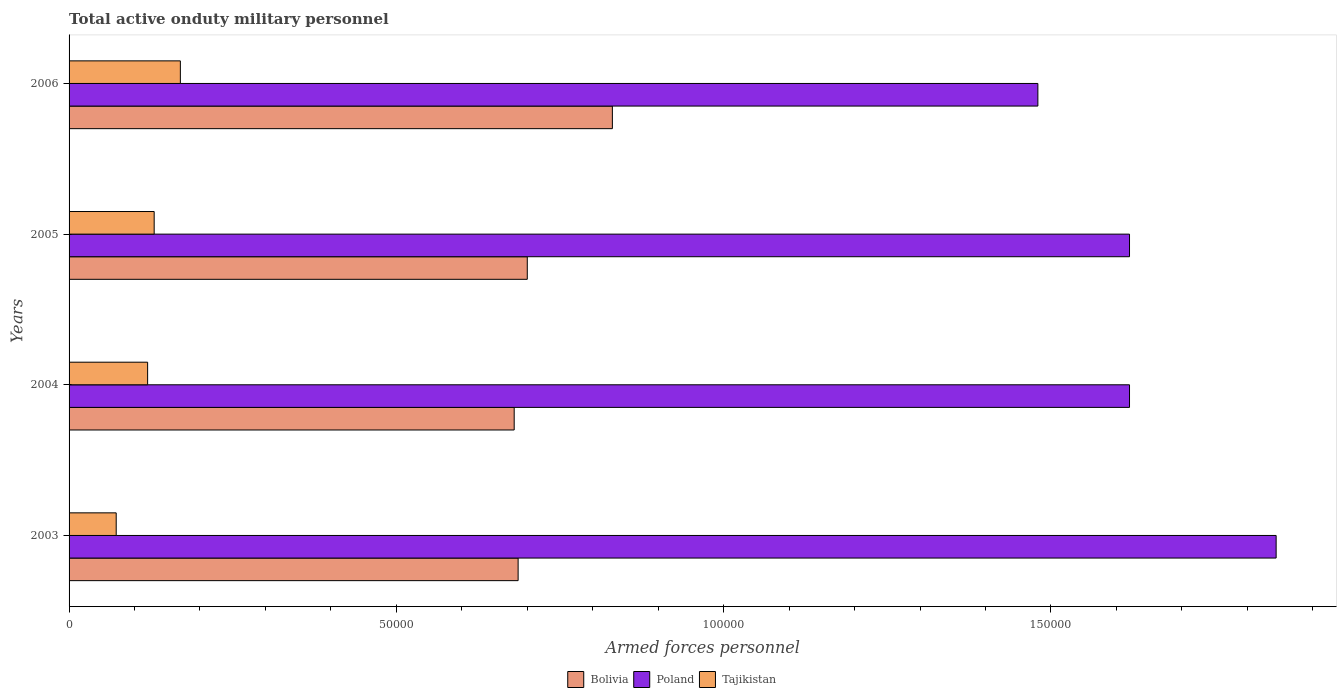How many different coloured bars are there?
Provide a succinct answer. 3. How many groups of bars are there?
Provide a short and direct response. 4. What is the number of armed forces personnel in Poland in 2004?
Make the answer very short. 1.62e+05. Across all years, what is the maximum number of armed forces personnel in Tajikistan?
Give a very brief answer. 1.70e+04. Across all years, what is the minimum number of armed forces personnel in Bolivia?
Make the answer very short. 6.80e+04. What is the total number of armed forces personnel in Poland in the graph?
Keep it short and to the point. 6.56e+05. What is the difference between the number of armed forces personnel in Tajikistan in 2003 and that in 2004?
Provide a succinct answer. -4800. What is the difference between the number of armed forces personnel in Tajikistan in 2004 and the number of armed forces personnel in Bolivia in 2006?
Keep it short and to the point. -7.10e+04. What is the average number of armed forces personnel in Bolivia per year?
Provide a short and direct response. 7.24e+04. In the year 2005, what is the difference between the number of armed forces personnel in Tajikistan and number of armed forces personnel in Poland?
Offer a terse response. -1.49e+05. What is the ratio of the number of armed forces personnel in Tajikistan in 2003 to that in 2006?
Your response must be concise. 0.42. Is the number of armed forces personnel in Poland in 2004 less than that in 2005?
Offer a very short reply. No. What is the difference between the highest and the second highest number of armed forces personnel in Bolivia?
Offer a terse response. 1.30e+04. What is the difference between the highest and the lowest number of armed forces personnel in Bolivia?
Offer a very short reply. 1.50e+04. What does the 1st bar from the top in 2005 represents?
Provide a succinct answer. Tajikistan. What does the 1st bar from the bottom in 2004 represents?
Provide a short and direct response. Bolivia. Are all the bars in the graph horizontal?
Offer a very short reply. Yes. Are the values on the major ticks of X-axis written in scientific E-notation?
Give a very brief answer. No. Does the graph contain grids?
Provide a short and direct response. No. Where does the legend appear in the graph?
Provide a short and direct response. Bottom center. How many legend labels are there?
Offer a terse response. 3. What is the title of the graph?
Provide a short and direct response. Total active onduty military personnel. What is the label or title of the X-axis?
Provide a short and direct response. Armed forces personnel. What is the label or title of the Y-axis?
Your answer should be compact. Years. What is the Armed forces personnel of Bolivia in 2003?
Keep it short and to the point. 6.86e+04. What is the Armed forces personnel in Poland in 2003?
Offer a terse response. 1.84e+05. What is the Armed forces personnel in Tajikistan in 2003?
Ensure brevity in your answer.  7200. What is the Armed forces personnel of Bolivia in 2004?
Ensure brevity in your answer.  6.80e+04. What is the Armed forces personnel in Poland in 2004?
Your answer should be very brief. 1.62e+05. What is the Armed forces personnel in Tajikistan in 2004?
Ensure brevity in your answer.  1.20e+04. What is the Armed forces personnel of Bolivia in 2005?
Keep it short and to the point. 7.00e+04. What is the Armed forces personnel in Poland in 2005?
Make the answer very short. 1.62e+05. What is the Armed forces personnel in Tajikistan in 2005?
Offer a very short reply. 1.30e+04. What is the Armed forces personnel in Bolivia in 2006?
Your answer should be very brief. 8.30e+04. What is the Armed forces personnel in Poland in 2006?
Make the answer very short. 1.48e+05. What is the Armed forces personnel in Tajikistan in 2006?
Make the answer very short. 1.70e+04. Across all years, what is the maximum Armed forces personnel of Bolivia?
Provide a succinct answer. 8.30e+04. Across all years, what is the maximum Armed forces personnel in Poland?
Offer a terse response. 1.84e+05. Across all years, what is the maximum Armed forces personnel in Tajikistan?
Make the answer very short. 1.70e+04. Across all years, what is the minimum Armed forces personnel in Bolivia?
Your answer should be compact. 6.80e+04. Across all years, what is the minimum Armed forces personnel of Poland?
Make the answer very short. 1.48e+05. Across all years, what is the minimum Armed forces personnel of Tajikistan?
Offer a terse response. 7200. What is the total Armed forces personnel of Bolivia in the graph?
Offer a very short reply. 2.90e+05. What is the total Armed forces personnel of Poland in the graph?
Make the answer very short. 6.56e+05. What is the total Armed forces personnel in Tajikistan in the graph?
Your answer should be compact. 4.92e+04. What is the difference between the Armed forces personnel of Bolivia in 2003 and that in 2004?
Your answer should be compact. 600. What is the difference between the Armed forces personnel of Poland in 2003 and that in 2004?
Your answer should be very brief. 2.24e+04. What is the difference between the Armed forces personnel in Tajikistan in 2003 and that in 2004?
Ensure brevity in your answer.  -4800. What is the difference between the Armed forces personnel of Bolivia in 2003 and that in 2005?
Your response must be concise. -1400. What is the difference between the Armed forces personnel of Poland in 2003 and that in 2005?
Provide a succinct answer. 2.24e+04. What is the difference between the Armed forces personnel in Tajikistan in 2003 and that in 2005?
Your answer should be compact. -5800. What is the difference between the Armed forces personnel of Bolivia in 2003 and that in 2006?
Provide a succinct answer. -1.44e+04. What is the difference between the Armed forces personnel of Poland in 2003 and that in 2006?
Ensure brevity in your answer.  3.64e+04. What is the difference between the Armed forces personnel of Tajikistan in 2003 and that in 2006?
Provide a succinct answer. -9800. What is the difference between the Armed forces personnel of Bolivia in 2004 and that in 2005?
Provide a short and direct response. -2000. What is the difference between the Armed forces personnel of Tajikistan in 2004 and that in 2005?
Keep it short and to the point. -1000. What is the difference between the Armed forces personnel of Bolivia in 2004 and that in 2006?
Keep it short and to the point. -1.50e+04. What is the difference between the Armed forces personnel in Poland in 2004 and that in 2006?
Keep it short and to the point. 1.40e+04. What is the difference between the Armed forces personnel of Tajikistan in 2004 and that in 2006?
Offer a very short reply. -5000. What is the difference between the Armed forces personnel in Bolivia in 2005 and that in 2006?
Your response must be concise. -1.30e+04. What is the difference between the Armed forces personnel of Poland in 2005 and that in 2006?
Offer a very short reply. 1.40e+04. What is the difference between the Armed forces personnel in Tajikistan in 2005 and that in 2006?
Offer a terse response. -4000. What is the difference between the Armed forces personnel of Bolivia in 2003 and the Armed forces personnel of Poland in 2004?
Ensure brevity in your answer.  -9.34e+04. What is the difference between the Armed forces personnel of Bolivia in 2003 and the Armed forces personnel of Tajikistan in 2004?
Ensure brevity in your answer.  5.66e+04. What is the difference between the Armed forces personnel in Poland in 2003 and the Armed forces personnel in Tajikistan in 2004?
Keep it short and to the point. 1.72e+05. What is the difference between the Armed forces personnel in Bolivia in 2003 and the Armed forces personnel in Poland in 2005?
Make the answer very short. -9.34e+04. What is the difference between the Armed forces personnel of Bolivia in 2003 and the Armed forces personnel of Tajikistan in 2005?
Offer a terse response. 5.56e+04. What is the difference between the Armed forces personnel in Poland in 2003 and the Armed forces personnel in Tajikistan in 2005?
Keep it short and to the point. 1.71e+05. What is the difference between the Armed forces personnel in Bolivia in 2003 and the Armed forces personnel in Poland in 2006?
Keep it short and to the point. -7.94e+04. What is the difference between the Armed forces personnel of Bolivia in 2003 and the Armed forces personnel of Tajikistan in 2006?
Your response must be concise. 5.16e+04. What is the difference between the Armed forces personnel of Poland in 2003 and the Armed forces personnel of Tajikistan in 2006?
Offer a terse response. 1.67e+05. What is the difference between the Armed forces personnel in Bolivia in 2004 and the Armed forces personnel in Poland in 2005?
Provide a short and direct response. -9.40e+04. What is the difference between the Armed forces personnel in Bolivia in 2004 and the Armed forces personnel in Tajikistan in 2005?
Your answer should be very brief. 5.50e+04. What is the difference between the Armed forces personnel in Poland in 2004 and the Armed forces personnel in Tajikistan in 2005?
Keep it short and to the point. 1.49e+05. What is the difference between the Armed forces personnel of Bolivia in 2004 and the Armed forces personnel of Poland in 2006?
Keep it short and to the point. -8.00e+04. What is the difference between the Armed forces personnel in Bolivia in 2004 and the Armed forces personnel in Tajikistan in 2006?
Provide a short and direct response. 5.10e+04. What is the difference between the Armed forces personnel in Poland in 2004 and the Armed forces personnel in Tajikistan in 2006?
Your response must be concise. 1.45e+05. What is the difference between the Armed forces personnel of Bolivia in 2005 and the Armed forces personnel of Poland in 2006?
Your answer should be very brief. -7.80e+04. What is the difference between the Armed forces personnel of Bolivia in 2005 and the Armed forces personnel of Tajikistan in 2006?
Your response must be concise. 5.30e+04. What is the difference between the Armed forces personnel in Poland in 2005 and the Armed forces personnel in Tajikistan in 2006?
Make the answer very short. 1.45e+05. What is the average Armed forces personnel of Bolivia per year?
Make the answer very short. 7.24e+04. What is the average Armed forces personnel of Poland per year?
Provide a succinct answer. 1.64e+05. What is the average Armed forces personnel of Tajikistan per year?
Offer a very short reply. 1.23e+04. In the year 2003, what is the difference between the Armed forces personnel in Bolivia and Armed forces personnel in Poland?
Provide a succinct answer. -1.16e+05. In the year 2003, what is the difference between the Armed forces personnel in Bolivia and Armed forces personnel in Tajikistan?
Offer a very short reply. 6.14e+04. In the year 2003, what is the difference between the Armed forces personnel of Poland and Armed forces personnel of Tajikistan?
Offer a very short reply. 1.77e+05. In the year 2004, what is the difference between the Armed forces personnel in Bolivia and Armed forces personnel in Poland?
Provide a short and direct response. -9.40e+04. In the year 2004, what is the difference between the Armed forces personnel of Bolivia and Armed forces personnel of Tajikistan?
Ensure brevity in your answer.  5.60e+04. In the year 2005, what is the difference between the Armed forces personnel of Bolivia and Armed forces personnel of Poland?
Offer a terse response. -9.20e+04. In the year 2005, what is the difference between the Armed forces personnel in Bolivia and Armed forces personnel in Tajikistan?
Your response must be concise. 5.70e+04. In the year 2005, what is the difference between the Armed forces personnel of Poland and Armed forces personnel of Tajikistan?
Ensure brevity in your answer.  1.49e+05. In the year 2006, what is the difference between the Armed forces personnel of Bolivia and Armed forces personnel of Poland?
Your answer should be compact. -6.50e+04. In the year 2006, what is the difference between the Armed forces personnel in Bolivia and Armed forces personnel in Tajikistan?
Your response must be concise. 6.60e+04. In the year 2006, what is the difference between the Armed forces personnel in Poland and Armed forces personnel in Tajikistan?
Your response must be concise. 1.31e+05. What is the ratio of the Armed forces personnel of Bolivia in 2003 to that in 2004?
Keep it short and to the point. 1.01. What is the ratio of the Armed forces personnel of Poland in 2003 to that in 2004?
Give a very brief answer. 1.14. What is the ratio of the Armed forces personnel of Tajikistan in 2003 to that in 2004?
Give a very brief answer. 0.6. What is the ratio of the Armed forces personnel in Bolivia in 2003 to that in 2005?
Provide a short and direct response. 0.98. What is the ratio of the Armed forces personnel in Poland in 2003 to that in 2005?
Ensure brevity in your answer.  1.14. What is the ratio of the Armed forces personnel of Tajikistan in 2003 to that in 2005?
Provide a short and direct response. 0.55. What is the ratio of the Armed forces personnel of Bolivia in 2003 to that in 2006?
Offer a terse response. 0.83. What is the ratio of the Armed forces personnel in Poland in 2003 to that in 2006?
Provide a succinct answer. 1.25. What is the ratio of the Armed forces personnel in Tajikistan in 2003 to that in 2006?
Ensure brevity in your answer.  0.42. What is the ratio of the Armed forces personnel in Bolivia in 2004 to that in 2005?
Provide a short and direct response. 0.97. What is the ratio of the Armed forces personnel of Poland in 2004 to that in 2005?
Keep it short and to the point. 1. What is the ratio of the Armed forces personnel in Tajikistan in 2004 to that in 2005?
Offer a terse response. 0.92. What is the ratio of the Armed forces personnel of Bolivia in 2004 to that in 2006?
Your response must be concise. 0.82. What is the ratio of the Armed forces personnel of Poland in 2004 to that in 2006?
Provide a succinct answer. 1.09. What is the ratio of the Armed forces personnel in Tajikistan in 2004 to that in 2006?
Make the answer very short. 0.71. What is the ratio of the Armed forces personnel in Bolivia in 2005 to that in 2006?
Provide a succinct answer. 0.84. What is the ratio of the Armed forces personnel in Poland in 2005 to that in 2006?
Your answer should be compact. 1.09. What is the ratio of the Armed forces personnel of Tajikistan in 2005 to that in 2006?
Your answer should be very brief. 0.76. What is the difference between the highest and the second highest Armed forces personnel in Bolivia?
Provide a short and direct response. 1.30e+04. What is the difference between the highest and the second highest Armed forces personnel in Poland?
Offer a very short reply. 2.24e+04. What is the difference between the highest and the second highest Armed forces personnel of Tajikistan?
Provide a succinct answer. 4000. What is the difference between the highest and the lowest Armed forces personnel in Bolivia?
Provide a succinct answer. 1.50e+04. What is the difference between the highest and the lowest Armed forces personnel of Poland?
Provide a short and direct response. 3.64e+04. What is the difference between the highest and the lowest Armed forces personnel of Tajikistan?
Provide a succinct answer. 9800. 